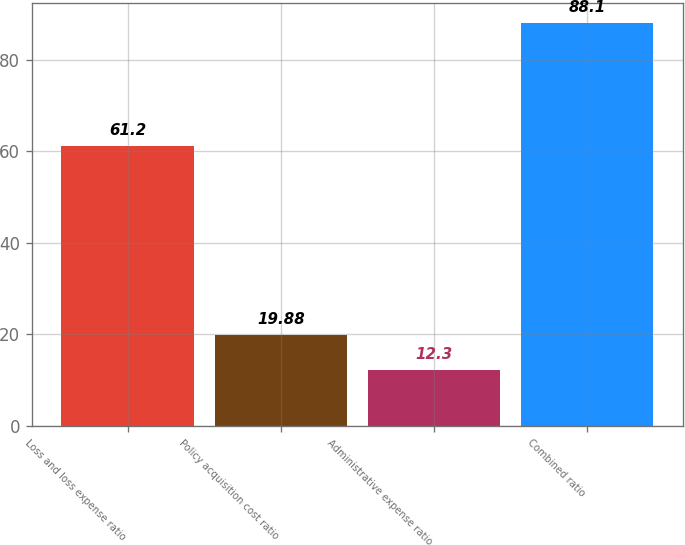Convert chart to OTSL. <chart><loc_0><loc_0><loc_500><loc_500><bar_chart><fcel>Loss and loss expense ratio<fcel>Policy acquisition cost ratio<fcel>Administrative expense ratio<fcel>Combined ratio<nl><fcel>61.2<fcel>19.88<fcel>12.3<fcel>88.1<nl></chart> 